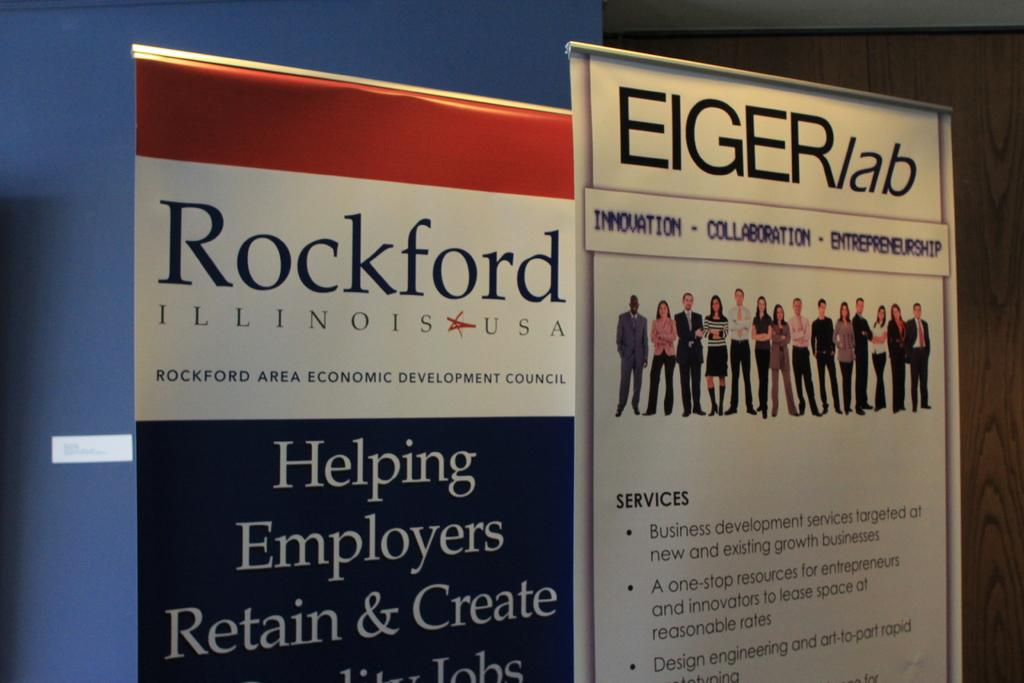<image>
Render a clear and concise summary of the photo. A red, white, and blue sign has the state Illinois on it. 